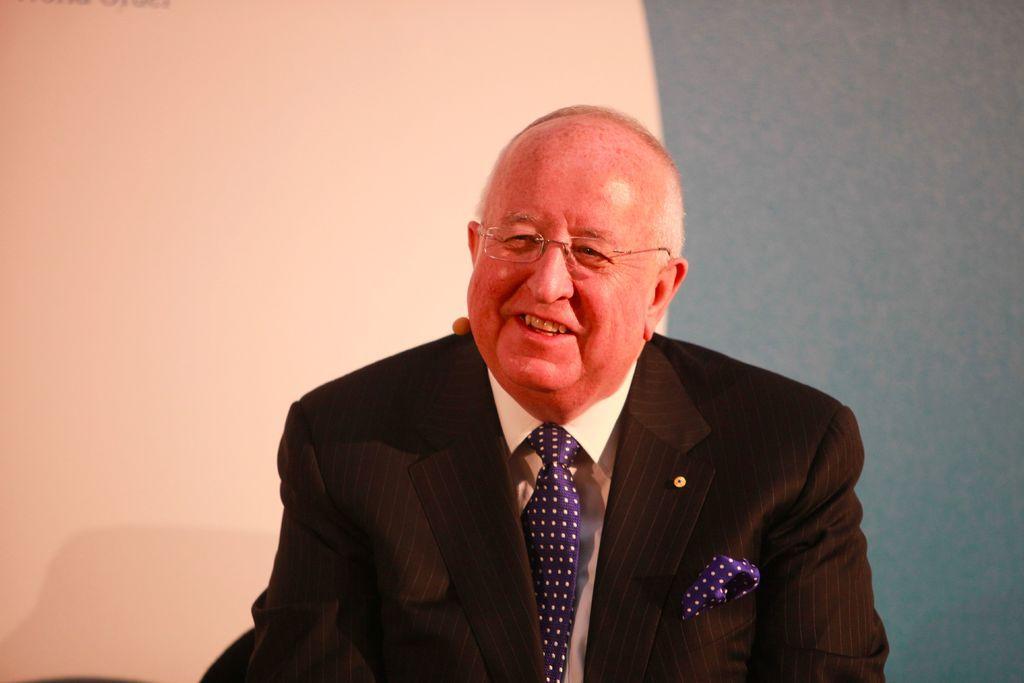How would you summarize this image in a sentence or two? In this picture, we see a man in white shirt and the black blazer is smiling. He is wearing the spectacles. On the left side, it is white in color. On the right side, we see a wall which is blue in color. 